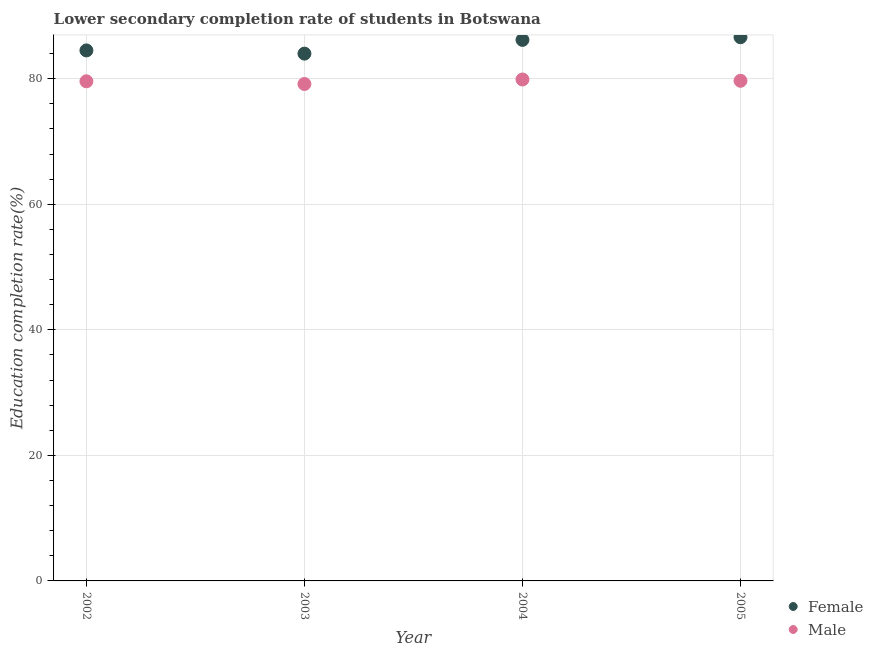What is the education completion rate of female students in 2005?
Offer a terse response. 86.62. Across all years, what is the maximum education completion rate of male students?
Your answer should be compact. 79.89. Across all years, what is the minimum education completion rate of female students?
Offer a terse response. 84.01. In which year was the education completion rate of female students maximum?
Give a very brief answer. 2005. What is the total education completion rate of female students in the graph?
Make the answer very short. 341.34. What is the difference between the education completion rate of male students in 2003 and that in 2004?
Ensure brevity in your answer.  -0.72. What is the difference between the education completion rate of male students in 2003 and the education completion rate of female students in 2002?
Offer a very short reply. -5.35. What is the average education completion rate of female students per year?
Offer a terse response. 85.33. In the year 2003, what is the difference between the education completion rate of female students and education completion rate of male students?
Your answer should be very brief. 4.84. In how many years, is the education completion rate of male students greater than 48 %?
Offer a very short reply. 4. What is the ratio of the education completion rate of female students in 2003 to that in 2005?
Provide a succinct answer. 0.97. What is the difference between the highest and the second highest education completion rate of male students?
Keep it short and to the point. 0.21. What is the difference between the highest and the lowest education completion rate of male students?
Make the answer very short. 0.72. Does the education completion rate of male students monotonically increase over the years?
Provide a short and direct response. No. Is the education completion rate of female students strictly greater than the education completion rate of male students over the years?
Offer a very short reply. Yes. Is the education completion rate of male students strictly less than the education completion rate of female students over the years?
Provide a short and direct response. Yes. How many years are there in the graph?
Your response must be concise. 4. What is the difference between two consecutive major ticks on the Y-axis?
Your answer should be very brief. 20. Are the values on the major ticks of Y-axis written in scientific E-notation?
Your answer should be compact. No. How many legend labels are there?
Offer a terse response. 2. What is the title of the graph?
Your response must be concise. Lower secondary completion rate of students in Botswana. What is the label or title of the Y-axis?
Give a very brief answer. Education completion rate(%). What is the Education completion rate(%) of Female in 2002?
Keep it short and to the point. 84.52. What is the Education completion rate(%) in Male in 2002?
Your answer should be compact. 79.6. What is the Education completion rate(%) in Female in 2003?
Provide a succinct answer. 84.01. What is the Education completion rate(%) of Male in 2003?
Your answer should be very brief. 79.17. What is the Education completion rate(%) of Female in 2004?
Your answer should be very brief. 86.19. What is the Education completion rate(%) of Male in 2004?
Offer a terse response. 79.89. What is the Education completion rate(%) of Female in 2005?
Offer a very short reply. 86.62. What is the Education completion rate(%) of Male in 2005?
Offer a very short reply. 79.68. Across all years, what is the maximum Education completion rate(%) of Female?
Provide a short and direct response. 86.62. Across all years, what is the maximum Education completion rate(%) of Male?
Keep it short and to the point. 79.89. Across all years, what is the minimum Education completion rate(%) in Female?
Give a very brief answer. 84.01. Across all years, what is the minimum Education completion rate(%) of Male?
Make the answer very short. 79.17. What is the total Education completion rate(%) of Female in the graph?
Make the answer very short. 341.34. What is the total Education completion rate(%) of Male in the graph?
Offer a terse response. 318.33. What is the difference between the Education completion rate(%) of Female in 2002 and that in 2003?
Offer a very short reply. 0.51. What is the difference between the Education completion rate(%) in Male in 2002 and that in 2003?
Ensure brevity in your answer.  0.43. What is the difference between the Education completion rate(%) of Female in 2002 and that in 2004?
Your response must be concise. -1.68. What is the difference between the Education completion rate(%) of Male in 2002 and that in 2004?
Provide a succinct answer. -0.29. What is the difference between the Education completion rate(%) in Female in 2002 and that in 2005?
Give a very brief answer. -2.1. What is the difference between the Education completion rate(%) in Male in 2002 and that in 2005?
Offer a terse response. -0.08. What is the difference between the Education completion rate(%) of Female in 2003 and that in 2004?
Make the answer very short. -2.19. What is the difference between the Education completion rate(%) in Male in 2003 and that in 2004?
Make the answer very short. -0.72. What is the difference between the Education completion rate(%) in Female in 2003 and that in 2005?
Offer a very short reply. -2.62. What is the difference between the Education completion rate(%) in Male in 2003 and that in 2005?
Offer a terse response. -0.51. What is the difference between the Education completion rate(%) in Female in 2004 and that in 2005?
Ensure brevity in your answer.  -0.43. What is the difference between the Education completion rate(%) of Male in 2004 and that in 2005?
Give a very brief answer. 0.21. What is the difference between the Education completion rate(%) in Female in 2002 and the Education completion rate(%) in Male in 2003?
Ensure brevity in your answer.  5.35. What is the difference between the Education completion rate(%) in Female in 2002 and the Education completion rate(%) in Male in 2004?
Offer a terse response. 4.63. What is the difference between the Education completion rate(%) in Female in 2002 and the Education completion rate(%) in Male in 2005?
Give a very brief answer. 4.84. What is the difference between the Education completion rate(%) in Female in 2003 and the Education completion rate(%) in Male in 2004?
Your answer should be very brief. 4.12. What is the difference between the Education completion rate(%) of Female in 2003 and the Education completion rate(%) of Male in 2005?
Offer a terse response. 4.33. What is the difference between the Education completion rate(%) in Female in 2004 and the Education completion rate(%) in Male in 2005?
Provide a succinct answer. 6.51. What is the average Education completion rate(%) of Female per year?
Offer a terse response. 85.33. What is the average Education completion rate(%) of Male per year?
Your response must be concise. 79.58. In the year 2002, what is the difference between the Education completion rate(%) of Female and Education completion rate(%) of Male?
Provide a succinct answer. 4.92. In the year 2003, what is the difference between the Education completion rate(%) in Female and Education completion rate(%) in Male?
Keep it short and to the point. 4.84. In the year 2004, what is the difference between the Education completion rate(%) in Female and Education completion rate(%) in Male?
Your response must be concise. 6.31. In the year 2005, what is the difference between the Education completion rate(%) of Female and Education completion rate(%) of Male?
Your answer should be compact. 6.94. What is the ratio of the Education completion rate(%) of Female in 2002 to that in 2003?
Your answer should be compact. 1.01. What is the ratio of the Education completion rate(%) in Male in 2002 to that in 2003?
Offer a very short reply. 1.01. What is the ratio of the Education completion rate(%) of Female in 2002 to that in 2004?
Keep it short and to the point. 0.98. What is the ratio of the Education completion rate(%) in Female in 2002 to that in 2005?
Provide a succinct answer. 0.98. What is the ratio of the Education completion rate(%) in Female in 2003 to that in 2004?
Keep it short and to the point. 0.97. What is the ratio of the Education completion rate(%) in Male in 2003 to that in 2004?
Give a very brief answer. 0.99. What is the ratio of the Education completion rate(%) of Female in 2003 to that in 2005?
Keep it short and to the point. 0.97. What is the ratio of the Education completion rate(%) in Female in 2004 to that in 2005?
Ensure brevity in your answer.  1. What is the difference between the highest and the second highest Education completion rate(%) in Female?
Give a very brief answer. 0.43. What is the difference between the highest and the second highest Education completion rate(%) of Male?
Offer a very short reply. 0.21. What is the difference between the highest and the lowest Education completion rate(%) in Female?
Offer a very short reply. 2.62. What is the difference between the highest and the lowest Education completion rate(%) of Male?
Ensure brevity in your answer.  0.72. 